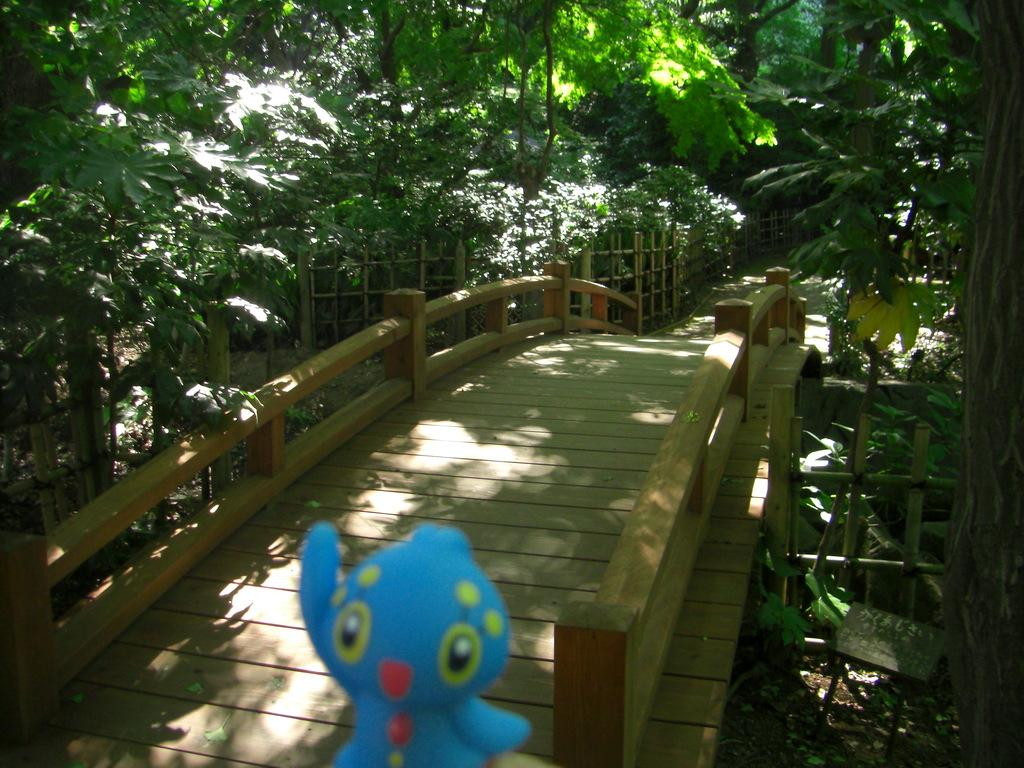What type of structure can be seen in the image? There is a bridge-like structure in the image. Is there anything on the bridge-like structure? Yes, a doll is present on the bridge-like structure. What type of natural elements can be seen in the image? There are trees and plants in the image. Can you tell me where the creator of the bridge-like structure is located in the image? There is no information about the creator of the bridge-like structure in the image, so it cannot be determined. 